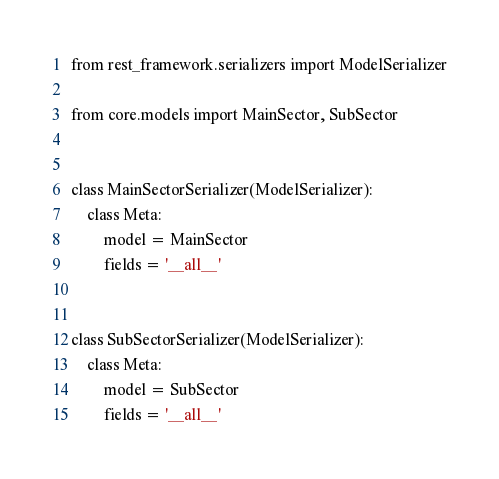Convert code to text. <code><loc_0><loc_0><loc_500><loc_500><_Python_>from rest_framework.serializers import ModelSerializer

from core.models import MainSector, SubSector


class MainSectorSerializer(ModelSerializer):
    class Meta:
        model = MainSector
        fields = '__all__'


class SubSectorSerializer(ModelSerializer):
    class Meta:
        model = SubSector
        fields = '__all__'
</code> 